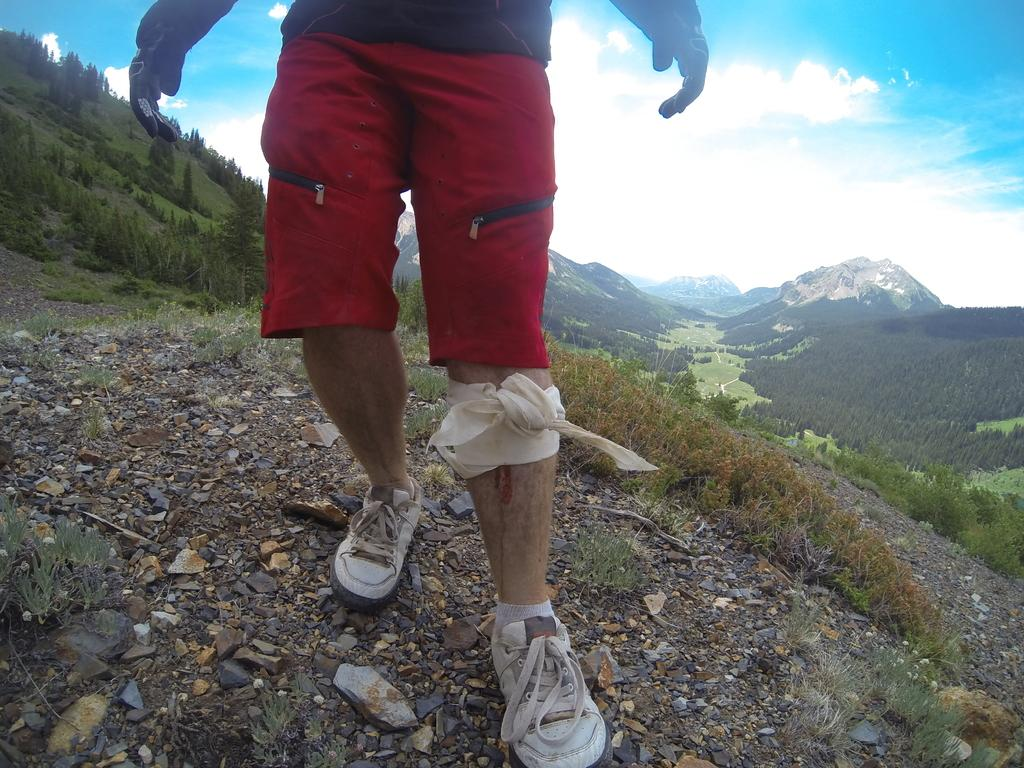What is present in the image? There is a person in the image. What type of natural environment is visible in the image? There is grass in the image. What can be seen in the background of the image? There are planets visible in the background of the image, as well as a mountain and the sky. What type of fruit is the person holding in the image? There is no fruit visible in the image. Can you see any injuries or wounds on the person in the image? There is no indication of any injuries or wounds on the person in the image. What type of tool is the person using to interact with the planets in the image? There is no tool visible in the image, and the person is not interacting with the planets. 